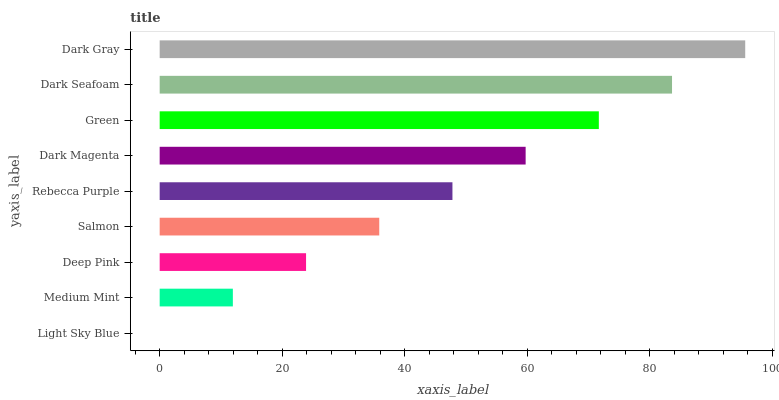Is Light Sky Blue the minimum?
Answer yes or no. Yes. Is Dark Gray the maximum?
Answer yes or no. Yes. Is Medium Mint the minimum?
Answer yes or no. No. Is Medium Mint the maximum?
Answer yes or no. No. Is Medium Mint greater than Light Sky Blue?
Answer yes or no. Yes. Is Light Sky Blue less than Medium Mint?
Answer yes or no. Yes. Is Light Sky Blue greater than Medium Mint?
Answer yes or no. No. Is Medium Mint less than Light Sky Blue?
Answer yes or no. No. Is Rebecca Purple the high median?
Answer yes or no. Yes. Is Rebecca Purple the low median?
Answer yes or no. Yes. Is Dark Seafoam the high median?
Answer yes or no. No. Is Medium Mint the low median?
Answer yes or no. No. 